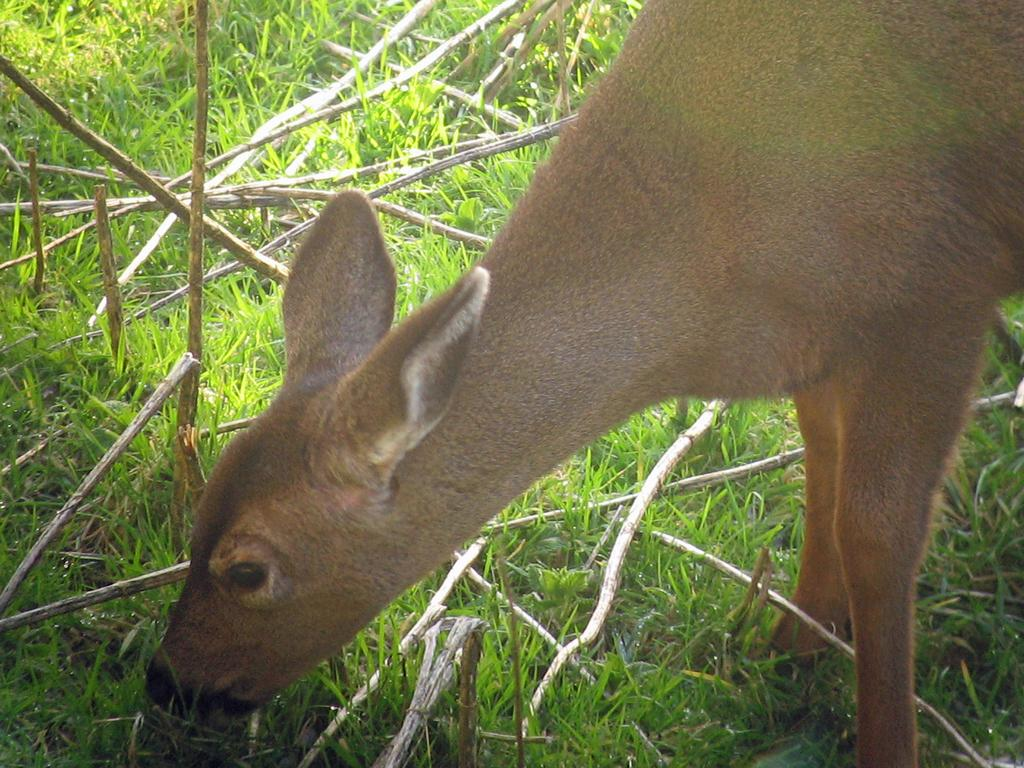What type of creature is present in the image? There is an animal in the image. Can you describe the color of the animal? The animal is brown in color. What type of vegetation can be seen in the image? There is green color grass in the image. What other objects are visible in the image? There are sticks visible in the image. What type of zinc is being used to build the animal's shelter in the image? There is no mention of zinc or a shelter in the image; it only features an animal, green grass, and sticks. 